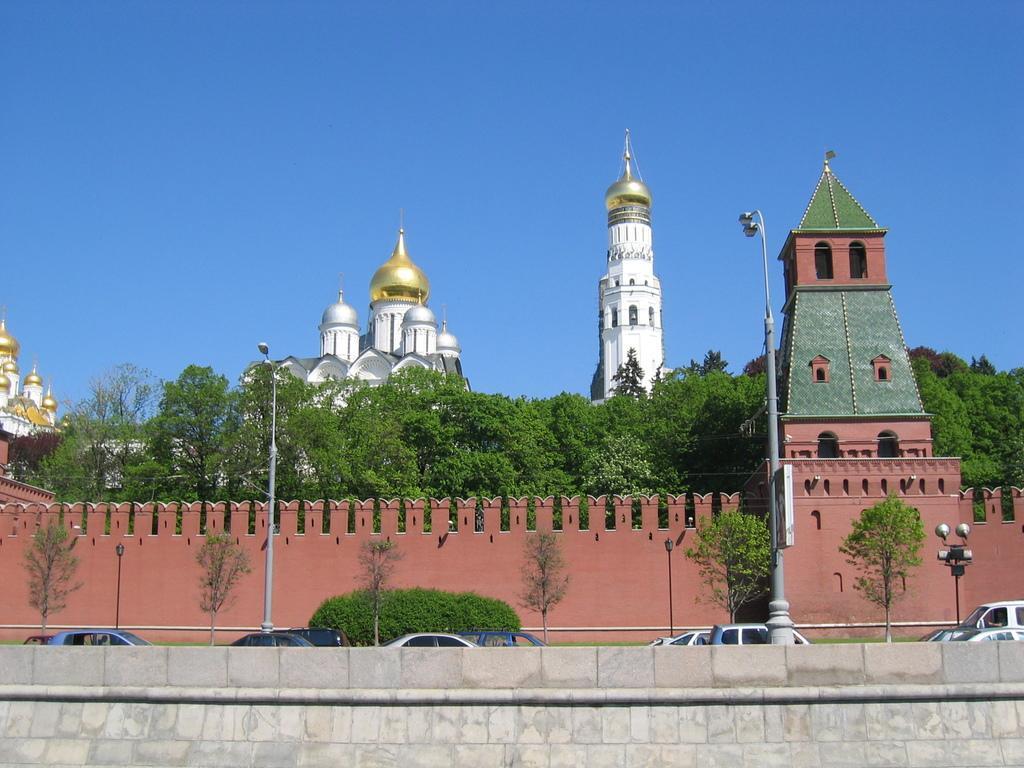Describe this image in one or two sentences. In this image we can see few buildings. There is a fence in the image. There are many trees and few plants in the image. There are few vehicles in the image. There are few street poles in the image. 